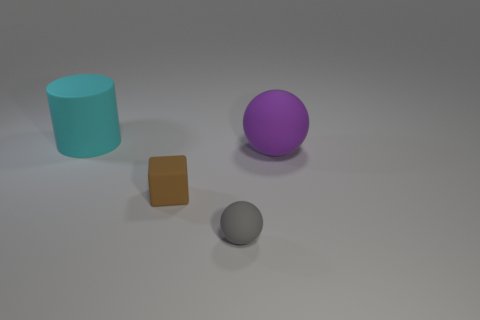Add 1 large red rubber spheres. How many objects exist? 5 Subtract all cylinders. How many objects are left? 3 Add 2 small gray matte balls. How many small gray matte balls exist? 3 Subtract 0 green cubes. How many objects are left? 4 Subtract all large brown objects. Subtract all purple rubber objects. How many objects are left? 3 Add 3 matte blocks. How many matte blocks are left? 4 